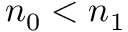Convert formula to latex. <formula><loc_0><loc_0><loc_500><loc_500>n _ { 0 } < n _ { 1 }</formula> 